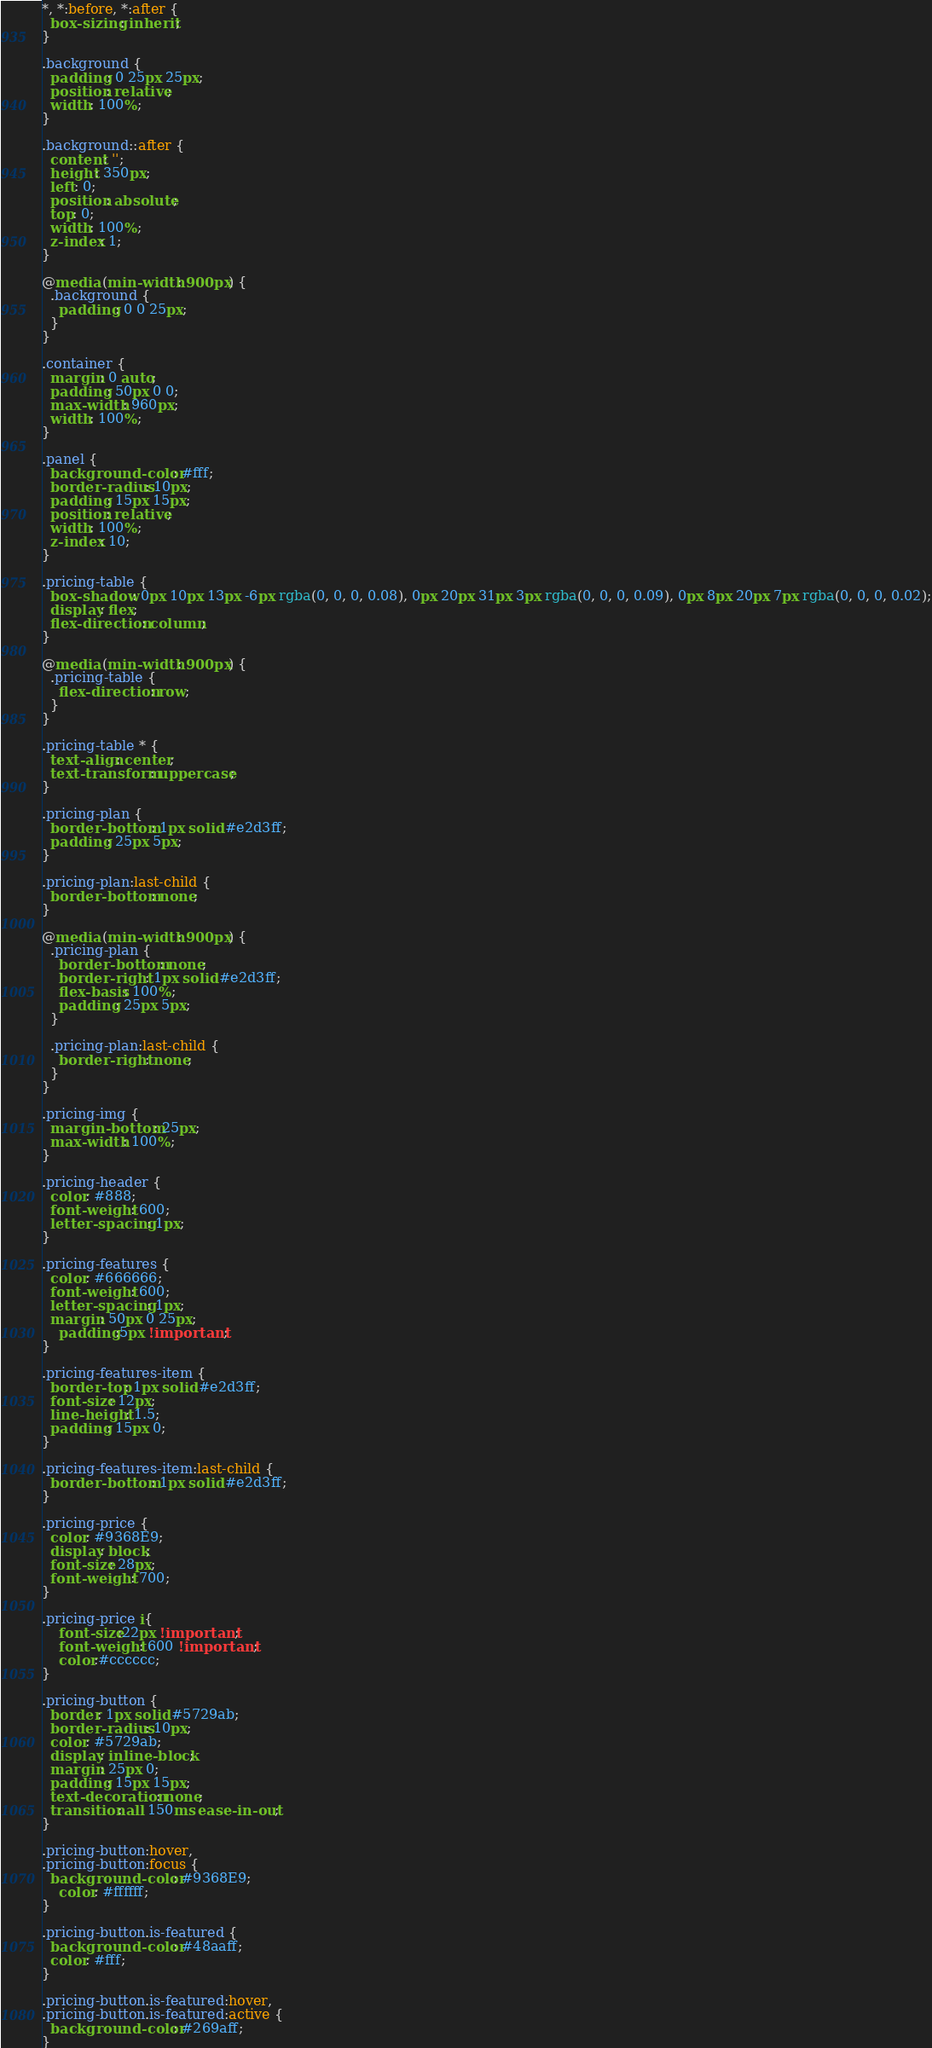Convert code to text. <code><loc_0><loc_0><loc_500><loc_500><_CSS_>*, *:before, *:after {
  box-sizing: inherit;
}

.background {
  padding: 0 25px 25px;
  position: relative;
  width: 100%;
}

.background::after {
  content: '';
  height: 350px;
  left: 0;
  position: absolute;
  top: 0;
  width: 100%;
  z-index: 1;
}

@media (min-width: 900px) {
  .background {
    padding: 0 0 25px;
  }
}

.container {
  margin: 0 auto;
  padding: 50px 0 0;
  max-width: 960px;
  width: 100%;
}

.panel {
  background-color: #fff;
  border-radius: 10px;
  padding: 15px 15px;
  position: relative;
  width: 100%;
  z-index: 10;
}

.pricing-table {
  box-shadow: 0px 10px 13px -6px rgba(0, 0, 0, 0.08), 0px 20px 31px 3px rgba(0, 0, 0, 0.09), 0px 8px 20px 7px rgba(0, 0, 0, 0.02);
  display: flex;
  flex-direction: column;
}

@media (min-width: 900px) {
  .pricing-table {
    flex-direction: row;
  }
}

.pricing-table * {
  text-align: center;
  text-transform: uppercase;
}

.pricing-plan {
  border-bottom: 1px solid #e2d3ff;
  padding: 25px 5px;
}

.pricing-plan:last-child {
  border-bottom: none;
}

@media (min-width: 900px) {
  .pricing-plan {
    border-bottom: none;
    border-right: 1px solid #e2d3ff;
    flex-basis: 100%;
    padding: 25px 5px;
  }

  .pricing-plan:last-child {
    border-right: none;
  }
}

.pricing-img {
  margin-bottom: 25px;
  max-width: 100%;
}

.pricing-header {
  color: #888;
  font-weight: 600;
  letter-spacing: 1px;
}

.pricing-features {
  color: #666666;
  font-weight: 600;
  letter-spacing: 1px;
  margin: 50px 0 25px;
	padding:5px !important;
}

.pricing-features-item {
  border-top: 1px solid #e2d3ff;
  font-size: 12px;
  line-height: 1.5;
  padding: 15px 0;
}

.pricing-features-item:last-child {
  border-bottom: 1px solid #e2d3ff;
}

.pricing-price {
  color: #9368E9;
  display: block;
  font-size: 28px;
  font-weight: 700;
}

.pricing-price i{
	font-size:22px !important;
	font-weight: 600 !important;
	color:#cccccc;
}

.pricing-button {
  border: 1px solid #5729ab;
  border-radius: 10px;
  color: #5729ab;
  display: inline-block;
  margin: 25px 0;
  padding: 15px 15px;
  text-decoration: none;
  transition: all 150ms ease-in-out;
}

.pricing-button:hover,
.pricing-button:focus {
  background-color: #9368E9;
	color: #ffffff;
}

.pricing-button.is-featured {
  background-color: #48aaff;
  color: #fff;
}

.pricing-button.is-featured:hover,
.pricing-button.is-featured:active {
  background-color: #269aff;
}
</code> 